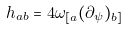<formula> <loc_0><loc_0><loc_500><loc_500>h _ { a b } = 4 \omega _ { [ a } ( \partial _ { \psi } ) _ { b ] }</formula> 